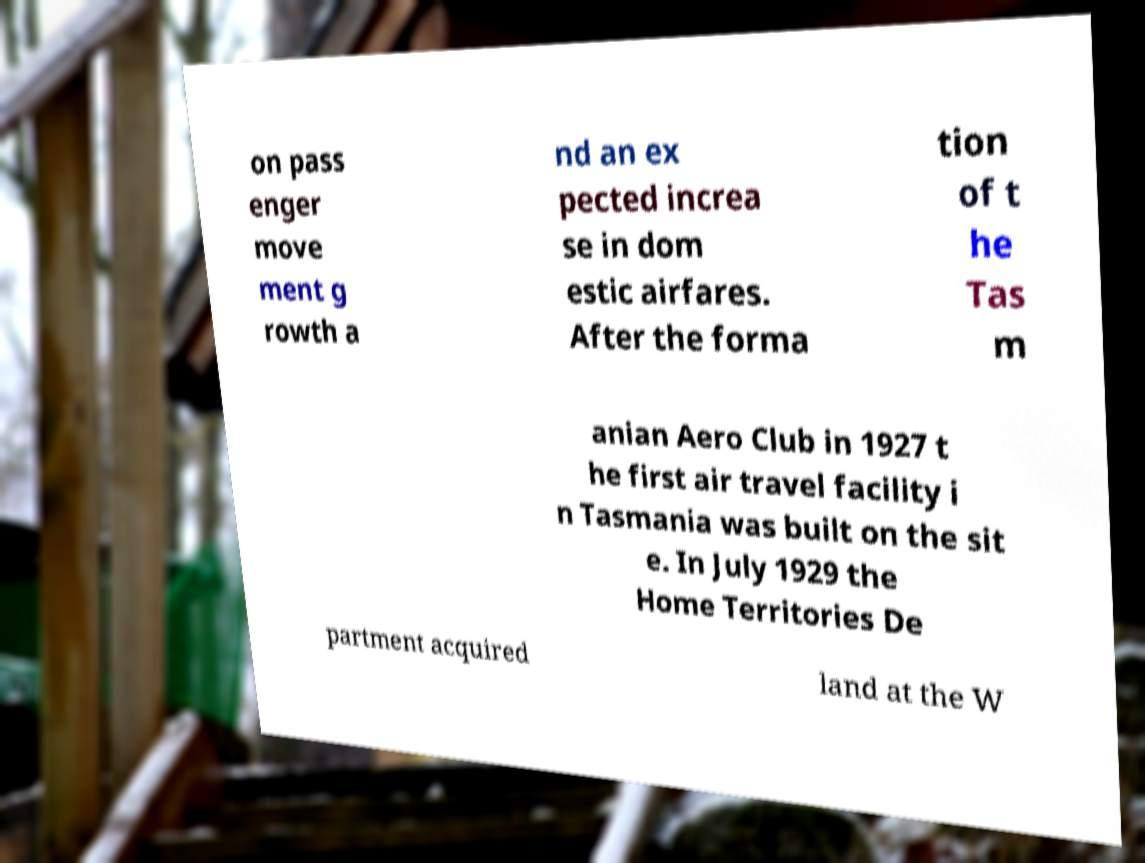Please read and relay the text visible in this image. What does it say? on pass enger move ment g rowth a nd an ex pected increa se in dom estic airfares. After the forma tion of t he Tas m anian Aero Club in 1927 t he first air travel facility i n Tasmania was built on the sit e. In July 1929 the Home Territories De partment acquired land at the W 